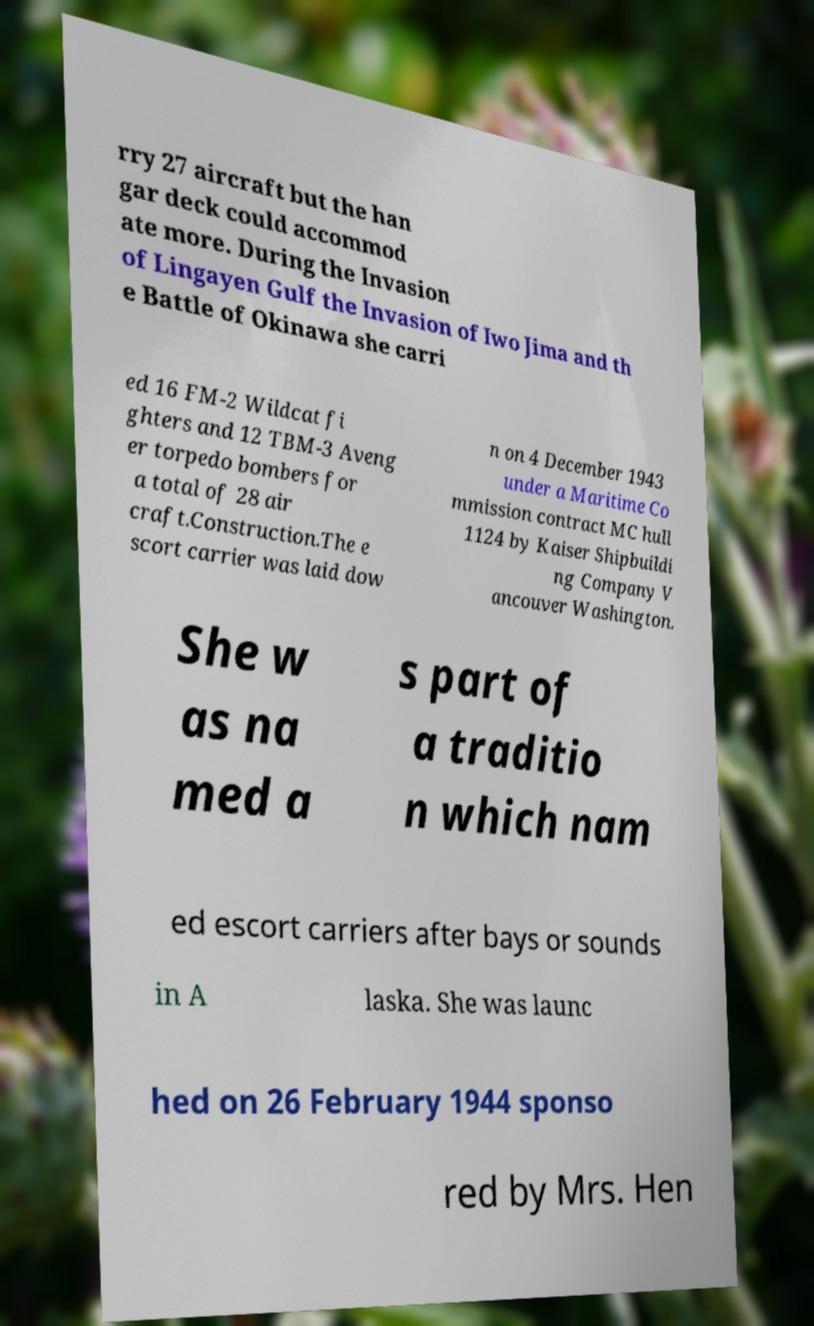Could you extract and type out the text from this image? rry 27 aircraft but the han gar deck could accommod ate more. During the Invasion of Lingayen Gulf the Invasion of Iwo Jima and th e Battle of Okinawa she carri ed 16 FM-2 Wildcat fi ghters and 12 TBM-3 Aveng er torpedo bombers for a total of 28 air craft.Construction.The e scort carrier was laid dow n on 4 December 1943 under a Maritime Co mmission contract MC hull 1124 by Kaiser Shipbuildi ng Company V ancouver Washington. She w as na med a s part of a traditio n which nam ed escort carriers after bays or sounds in A laska. She was launc hed on 26 February 1944 sponso red by Mrs. Hen 